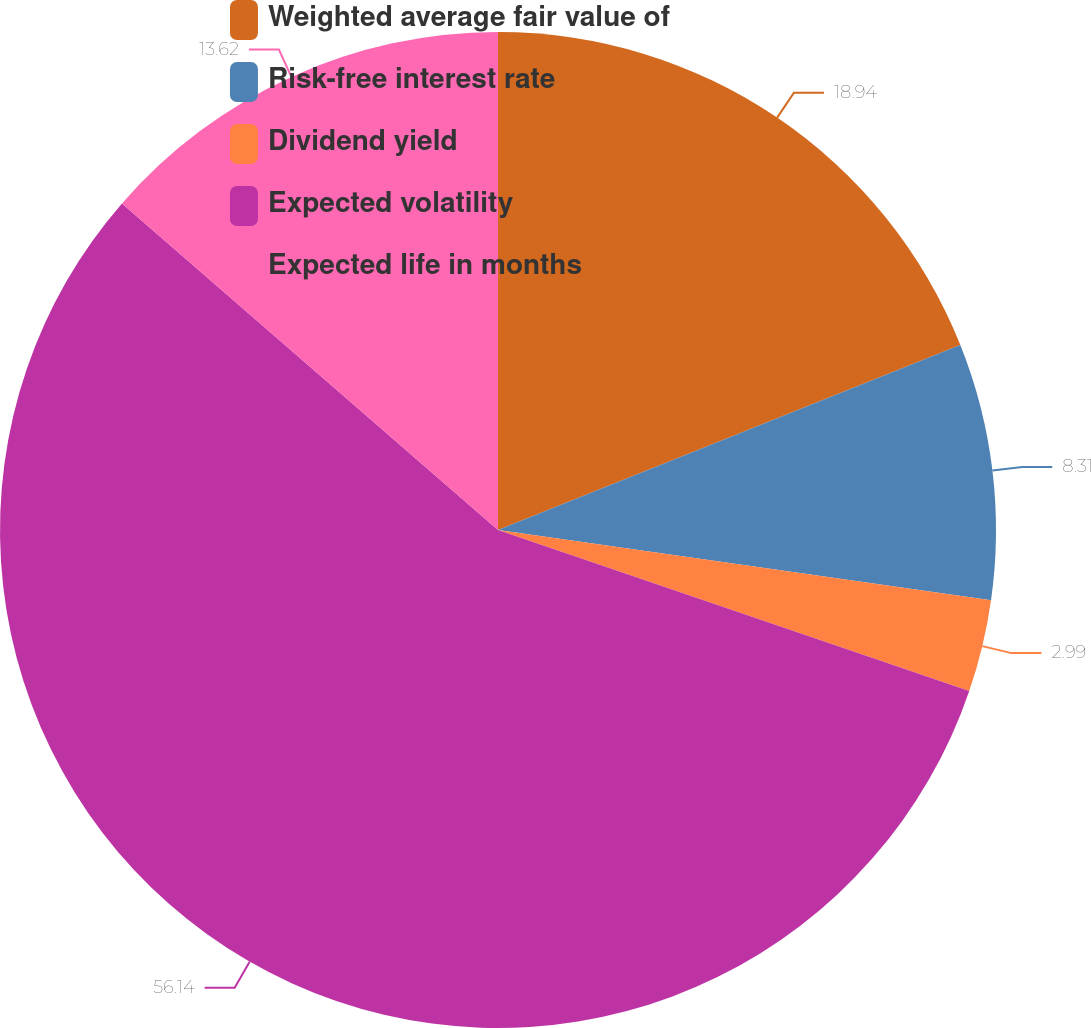<chart> <loc_0><loc_0><loc_500><loc_500><pie_chart><fcel>Weighted average fair value of<fcel>Risk-free interest rate<fcel>Dividend yield<fcel>Expected volatility<fcel>Expected life in months<nl><fcel>18.94%<fcel>8.31%<fcel>2.99%<fcel>56.14%<fcel>13.62%<nl></chart> 